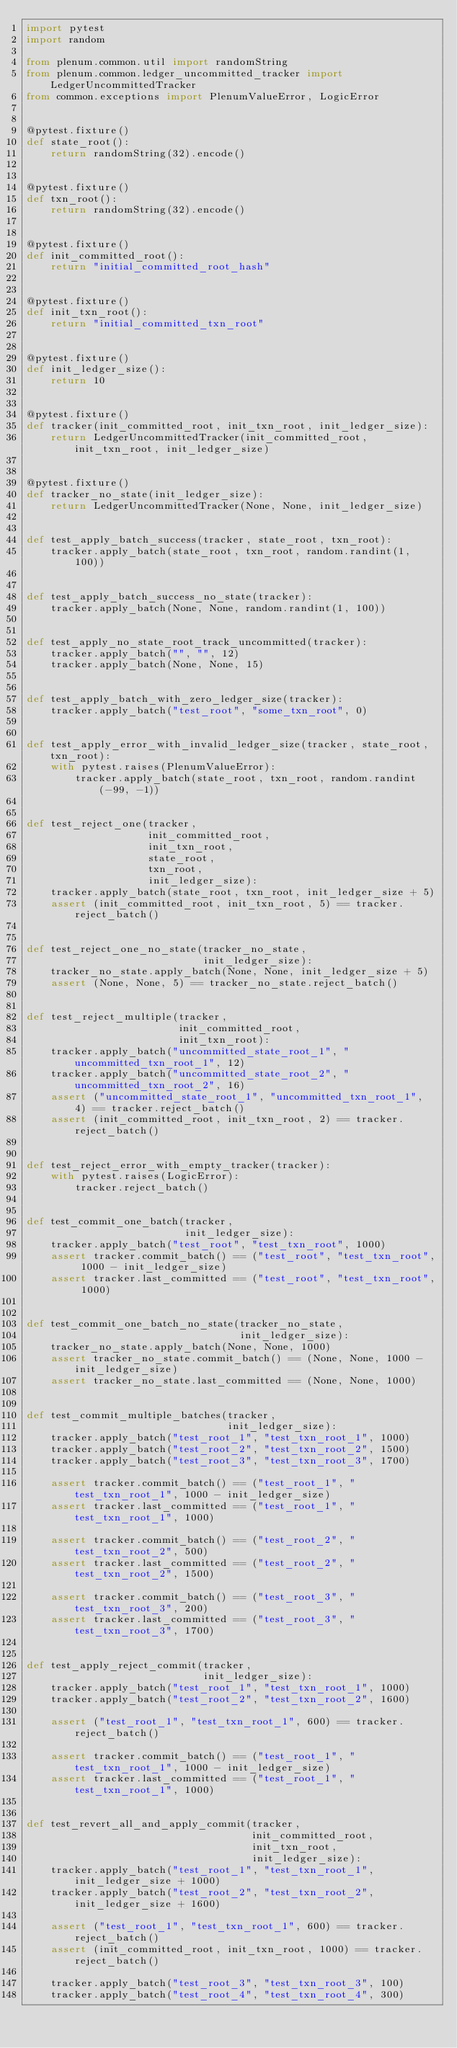<code> <loc_0><loc_0><loc_500><loc_500><_Python_>import pytest
import random

from plenum.common.util import randomString
from plenum.common.ledger_uncommitted_tracker import LedgerUncommittedTracker
from common.exceptions import PlenumValueError, LogicError


@pytest.fixture()
def state_root():
    return randomString(32).encode()


@pytest.fixture()
def txn_root():
    return randomString(32).encode()


@pytest.fixture()
def init_committed_root():
    return "initial_committed_root_hash"


@pytest.fixture()
def init_txn_root():
    return "initial_committed_txn_root"


@pytest.fixture()
def init_ledger_size():
    return 10


@pytest.fixture()
def tracker(init_committed_root, init_txn_root, init_ledger_size):
    return LedgerUncommittedTracker(init_committed_root, init_txn_root, init_ledger_size)


@pytest.fixture()
def tracker_no_state(init_ledger_size):
    return LedgerUncommittedTracker(None, None, init_ledger_size)


def test_apply_batch_success(tracker, state_root, txn_root):
    tracker.apply_batch(state_root, txn_root, random.randint(1, 100))


def test_apply_batch_success_no_state(tracker):
    tracker.apply_batch(None, None, random.randint(1, 100))


def test_apply_no_state_root_track_uncommitted(tracker):
    tracker.apply_batch("", "", 12)
    tracker.apply_batch(None, None, 15)


def test_apply_batch_with_zero_ledger_size(tracker):
    tracker.apply_batch("test_root", "some_txn_root", 0)


def test_apply_error_with_invalid_ledger_size(tracker, state_root, txn_root):
    with pytest.raises(PlenumValueError):
        tracker.apply_batch(state_root, txn_root, random.randint(-99, -1))


def test_reject_one(tracker,
                    init_committed_root,
                    init_txn_root,
                    state_root,
                    txn_root,
                    init_ledger_size):
    tracker.apply_batch(state_root, txn_root, init_ledger_size + 5)
    assert (init_committed_root, init_txn_root, 5) == tracker.reject_batch()


def test_reject_one_no_state(tracker_no_state,
                             init_ledger_size):
    tracker_no_state.apply_batch(None, None, init_ledger_size + 5)
    assert (None, None, 5) == tracker_no_state.reject_batch()


def test_reject_multiple(tracker,
                         init_committed_root,
                         init_txn_root):
    tracker.apply_batch("uncommitted_state_root_1", "uncommitted_txn_root_1", 12)
    tracker.apply_batch("uncommitted_state_root_2", "uncommitted_txn_root_2", 16)
    assert ("uncommitted_state_root_1", "uncommitted_txn_root_1", 4) == tracker.reject_batch()
    assert (init_committed_root, init_txn_root, 2) == tracker.reject_batch()


def test_reject_error_with_empty_tracker(tracker):
    with pytest.raises(LogicError):
        tracker.reject_batch()


def test_commit_one_batch(tracker,
                          init_ledger_size):
    tracker.apply_batch("test_root", "test_txn_root", 1000)
    assert tracker.commit_batch() == ("test_root", "test_txn_root", 1000 - init_ledger_size)
    assert tracker.last_committed == ("test_root", "test_txn_root", 1000)


def test_commit_one_batch_no_state(tracker_no_state,
                                   init_ledger_size):
    tracker_no_state.apply_batch(None, None, 1000)
    assert tracker_no_state.commit_batch() == (None, None, 1000 - init_ledger_size)
    assert tracker_no_state.last_committed == (None, None, 1000)


def test_commit_multiple_batches(tracker,
                                 init_ledger_size):
    tracker.apply_batch("test_root_1", "test_txn_root_1", 1000)
    tracker.apply_batch("test_root_2", "test_txn_root_2", 1500)
    tracker.apply_batch("test_root_3", "test_txn_root_3", 1700)

    assert tracker.commit_batch() == ("test_root_1", "test_txn_root_1", 1000 - init_ledger_size)
    assert tracker.last_committed == ("test_root_1", "test_txn_root_1", 1000)

    assert tracker.commit_batch() == ("test_root_2", "test_txn_root_2", 500)
    assert tracker.last_committed == ("test_root_2", "test_txn_root_2", 1500)

    assert tracker.commit_batch() == ("test_root_3", "test_txn_root_3", 200)
    assert tracker.last_committed == ("test_root_3", "test_txn_root_3", 1700)


def test_apply_reject_commit(tracker,
                             init_ledger_size):
    tracker.apply_batch("test_root_1", "test_txn_root_1", 1000)
    tracker.apply_batch("test_root_2", "test_txn_root_2", 1600)

    assert ("test_root_1", "test_txn_root_1", 600) == tracker.reject_batch()

    assert tracker.commit_batch() == ("test_root_1", "test_txn_root_1", 1000 - init_ledger_size)
    assert tracker.last_committed == ("test_root_1", "test_txn_root_1", 1000)


def test_revert_all_and_apply_commit(tracker,
                                     init_committed_root,
                                     init_txn_root,
                                     init_ledger_size):
    tracker.apply_batch("test_root_1", "test_txn_root_1", init_ledger_size + 1000)
    tracker.apply_batch("test_root_2", "test_txn_root_2", init_ledger_size + 1600)

    assert ("test_root_1", "test_txn_root_1", 600) == tracker.reject_batch()
    assert (init_committed_root, init_txn_root, 1000) == tracker.reject_batch()

    tracker.apply_batch("test_root_3", "test_txn_root_3", 100)
    tracker.apply_batch("test_root_4", "test_txn_root_4", 300)
</code> 